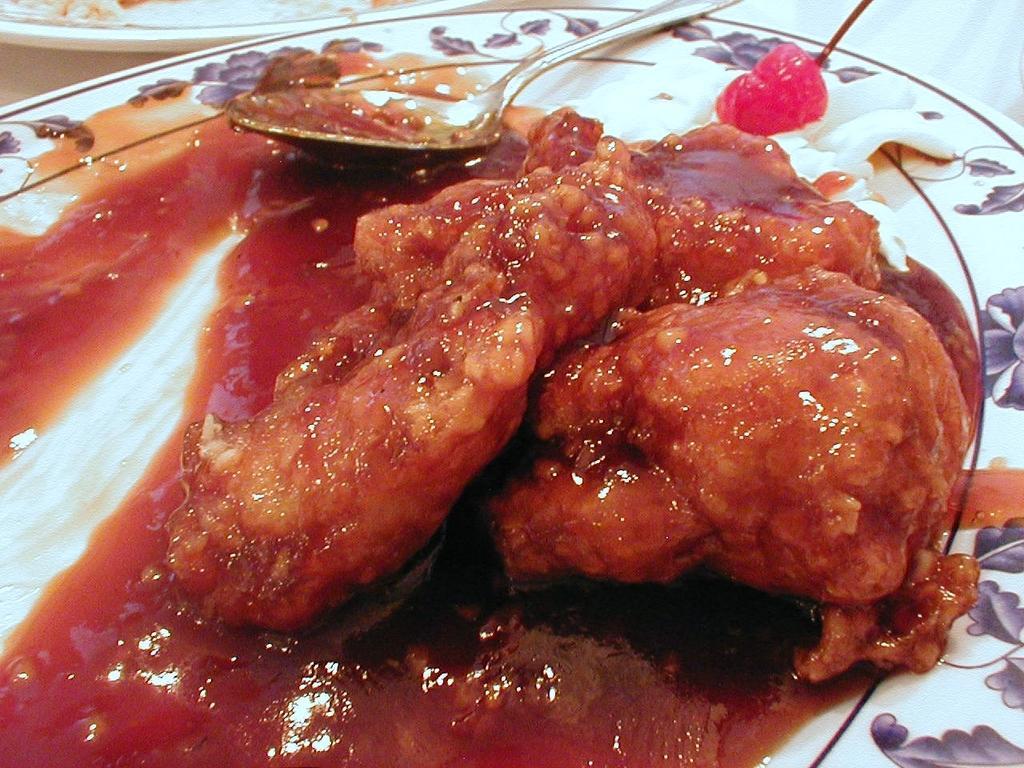How would you summarize this image in a sentence or two? In this image at the bottom there is one plate, in that place there are some food items and one spoon and on the top of the image there is another plate. 